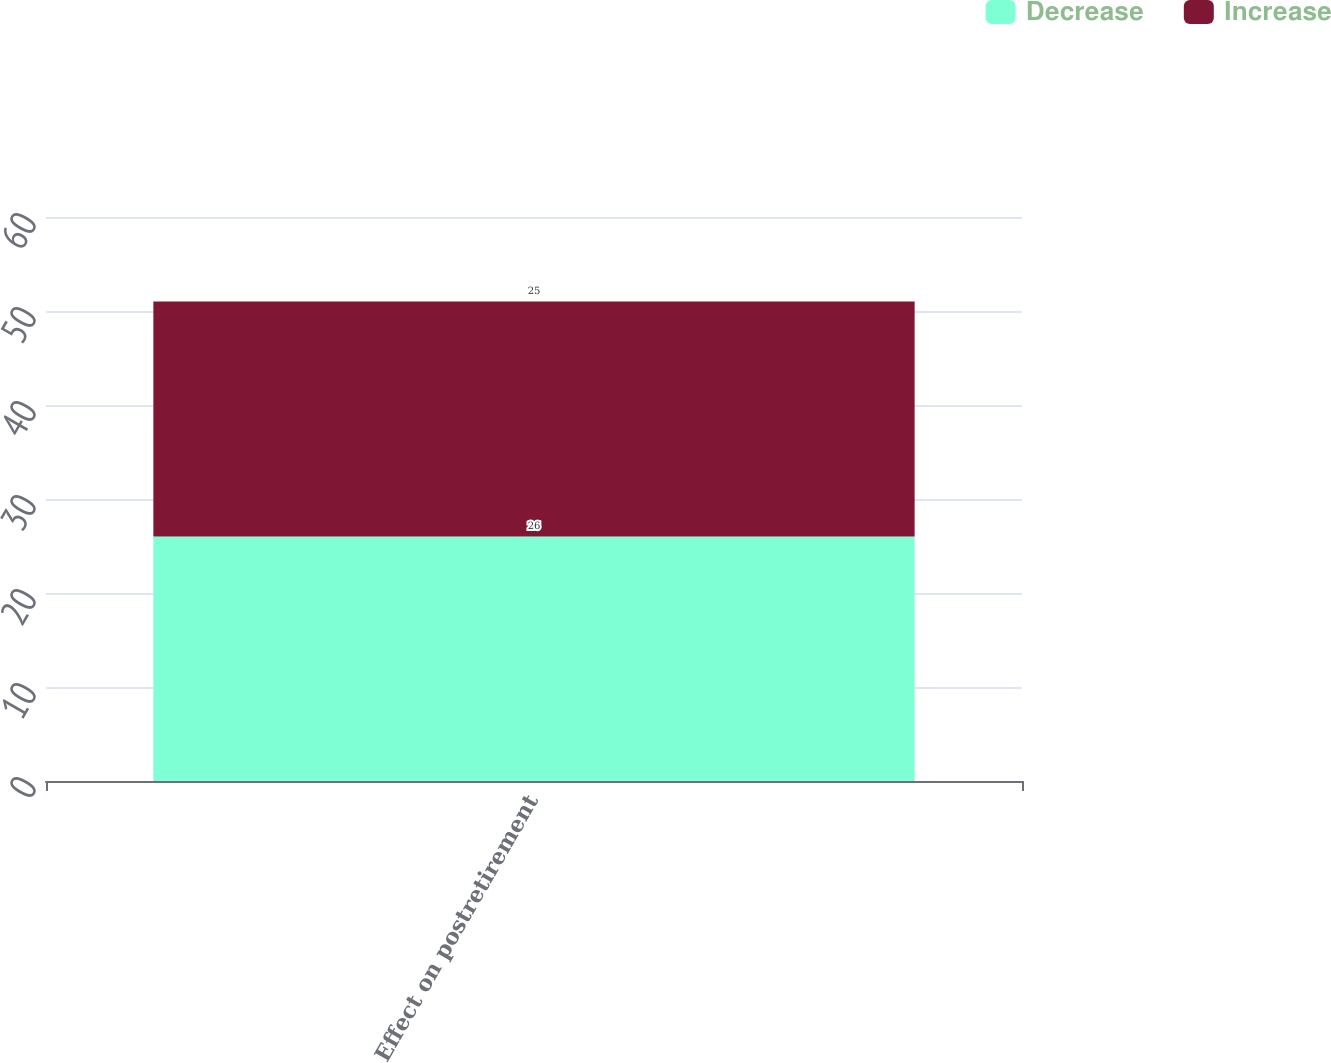Convert chart. <chart><loc_0><loc_0><loc_500><loc_500><stacked_bar_chart><ecel><fcel>Effect on postretirement<nl><fcel>Decrease<fcel>26<nl><fcel>Increase<fcel>25<nl></chart> 